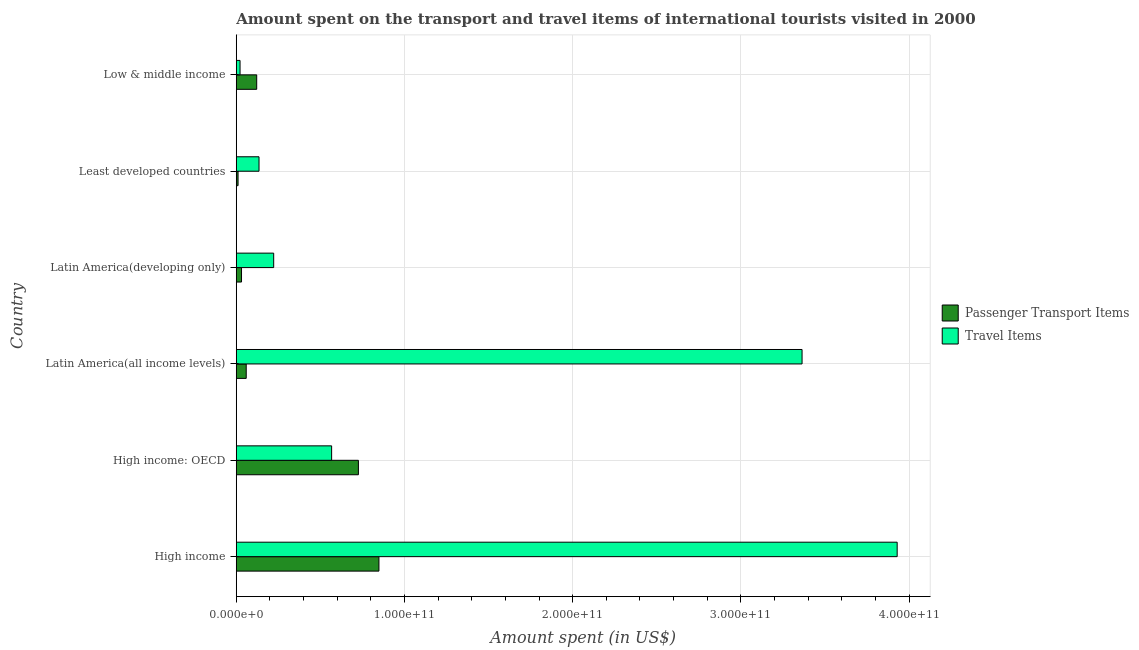How many groups of bars are there?
Your answer should be very brief. 6. Are the number of bars per tick equal to the number of legend labels?
Make the answer very short. Yes. Are the number of bars on each tick of the Y-axis equal?
Keep it short and to the point. Yes. How many bars are there on the 4th tick from the top?
Offer a terse response. 2. What is the label of the 1st group of bars from the top?
Your answer should be very brief. Low & middle income. In how many cases, is the number of bars for a given country not equal to the number of legend labels?
Your answer should be compact. 0. What is the amount spent on passenger transport items in High income?
Keep it short and to the point. 8.48e+1. Across all countries, what is the maximum amount spent in travel items?
Offer a terse response. 3.93e+11. Across all countries, what is the minimum amount spent on passenger transport items?
Provide a short and direct response. 1.08e+09. In which country was the amount spent on passenger transport items minimum?
Ensure brevity in your answer.  Least developed countries. What is the total amount spent in travel items in the graph?
Keep it short and to the point. 8.24e+11. What is the difference between the amount spent in travel items in High income and that in High income: OECD?
Offer a terse response. 3.36e+11. What is the difference between the amount spent on passenger transport items in High income and the amount spent in travel items in Latin America(all income levels)?
Keep it short and to the point. -2.52e+11. What is the average amount spent in travel items per country?
Ensure brevity in your answer.  1.37e+11. What is the difference between the amount spent in travel items and amount spent on passenger transport items in Least developed countries?
Provide a short and direct response. 1.25e+1. What is the ratio of the amount spent on passenger transport items in High income: OECD to that in Least developed countries?
Ensure brevity in your answer.  67.43. What is the difference between the highest and the second highest amount spent in travel items?
Ensure brevity in your answer.  5.65e+1. What is the difference between the highest and the lowest amount spent on passenger transport items?
Your answer should be very brief. 8.37e+1. In how many countries, is the amount spent in travel items greater than the average amount spent in travel items taken over all countries?
Ensure brevity in your answer.  2. What does the 2nd bar from the top in Least developed countries represents?
Make the answer very short. Passenger Transport Items. What does the 1st bar from the bottom in High income represents?
Keep it short and to the point. Passenger Transport Items. Are all the bars in the graph horizontal?
Keep it short and to the point. Yes. How many countries are there in the graph?
Provide a succinct answer. 6. What is the difference between two consecutive major ticks on the X-axis?
Your answer should be compact. 1.00e+11. Are the values on the major ticks of X-axis written in scientific E-notation?
Your answer should be compact. Yes. Does the graph contain any zero values?
Your answer should be very brief. No. Where does the legend appear in the graph?
Offer a terse response. Center right. How many legend labels are there?
Keep it short and to the point. 2. How are the legend labels stacked?
Make the answer very short. Vertical. What is the title of the graph?
Your response must be concise. Amount spent on the transport and travel items of international tourists visited in 2000. Does "Lowest 10% of population" appear as one of the legend labels in the graph?
Provide a short and direct response. No. What is the label or title of the X-axis?
Offer a very short reply. Amount spent (in US$). What is the label or title of the Y-axis?
Your answer should be very brief. Country. What is the Amount spent (in US$) of Passenger Transport Items in High income?
Keep it short and to the point. 8.48e+1. What is the Amount spent (in US$) in Travel Items in High income?
Provide a short and direct response. 3.93e+11. What is the Amount spent (in US$) in Passenger Transport Items in High income: OECD?
Your answer should be very brief. 7.26e+1. What is the Amount spent (in US$) of Travel Items in High income: OECD?
Keep it short and to the point. 5.67e+1. What is the Amount spent (in US$) in Passenger Transport Items in Latin America(all income levels)?
Give a very brief answer. 5.93e+09. What is the Amount spent (in US$) of Travel Items in Latin America(all income levels)?
Offer a very short reply. 3.36e+11. What is the Amount spent (in US$) in Passenger Transport Items in Latin America(developing only)?
Your answer should be very brief. 3.13e+09. What is the Amount spent (in US$) in Travel Items in Latin America(developing only)?
Provide a succinct answer. 2.23e+1. What is the Amount spent (in US$) in Passenger Transport Items in Least developed countries?
Keep it short and to the point. 1.08e+09. What is the Amount spent (in US$) in Travel Items in Least developed countries?
Make the answer very short. 1.35e+1. What is the Amount spent (in US$) in Passenger Transport Items in Low & middle income?
Offer a very short reply. 1.22e+1. What is the Amount spent (in US$) in Travel Items in Low & middle income?
Give a very brief answer. 2.26e+09. Across all countries, what is the maximum Amount spent (in US$) of Passenger Transport Items?
Your response must be concise. 8.48e+1. Across all countries, what is the maximum Amount spent (in US$) in Travel Items?
Keep it short and to the point. 3.93e+11. Across all countries, what is the minimum Amount spent (in US$) in Passenger Transport Items?
Your response must be concise. 1.08e+09. Across all countries, what is the minimum Amount spent (in US$) in Travel Items?
Provide a short and direct response. 2.26e+09. What is the total Amount spent (in US$) of Passenger Transport Items in the graph?
Ensure brevity in your answer.  1.80e+11. What is the total Amount spent (in US$) in Travel Items in the graph?
Provide a succinct answer. 8.24e+11. What is the difference between the Amount spent (in US$) of Passenger Transport Items in High income and that in High income: OECD?
Provide a succinct answer. 1.22e+1. What is the difference between the Amount spent (in US$) of Travel Items in High income and that in High income: OECD?
Give a very brief answer. 3.36e+11. What is the difference between the Amount spent (in US$) in Passenger Transport Items in High income and that in Latin America(all income levels)?
Make the answer very short. 7.89e+1. What is the difference between the Amount spent (in US$) of Travel Items in High income and that in Latin America(all income levels)?
Offer a terse response. 5.65e+1. What is the difference between the Amount spent (in US$) of Passenger Transport Items in High income and that in Latin America(developing only)?
Your answer should be compact. 8.17e+1. What is the difference between the Amount spent (in US$) in Travel Items in High income and that in Latin America(developing only)?
Make the answer very short. 3.71e+11. What is the difference between the Amount spent (in US$) of Passenger Transport Items in High income and that in Least developed countries?
Ensure brevity in your answer.  8.37e+1. What is the difference between the Amount spent (in US$) of Travel Items in High income and that in Least developed countries?
Make the answer very short. 3.79e+11. What is the difference between the Amount spent (in US$) of Passenger Transport Items in High income and that in Low & middle income?
Ensure brevity in your answer.  7.27e+1. What is the difference between the Amount spent (in US$) of Travel Items in High income and that in Low & middle income?
Ensure brevity in your answer.  3.91e+11. What is the difference between the Amount spent (in US$) in Passenger Transport Items in High income: OECD and that in Latin America(all income levels)?
Your answer should be very brief. 6.67e+1. What is the difference between the Amount spent (in US$) of Travel Items in High income: OECD and that in Latin America(all income levels)?
Keep it short and to the point. -2.80e+11. What is the difference between the Amount spent (in US$) of Passenger Transport Items in High income: OECD and that in Latin America(developing only)?
Keep it short and to the point. 6.95e+1. What is the difference between the Amount spent (in US$) in Travel Items in High income: OECD and that in Latin America(developing only)?
Offer a very short reply. 3.44e+1. What is the difference between the Amount spent (in US$) in Passenger Transport Items in High income: OECD and that in Least developed countries?
Give a very brief answer. 7.15e+1. What is the difference between the Amount spent (in US$) in Travel Items in High income: OECD and that in Least developed countries?
Ensure brevity in your answer.  4.32e+1. What is the difference between the Amount spent (in US$) of Passenger Transport Items in High income: OECD and that in Low & middle income?
Your response must be concise. 6.05e+1. What is the difference between the Amount spent (in US$) in Travel Items in High income: OECD and that in Low & middle income?
Offer a terse response. 5.44e+1. What is the difference between the Amount spent (in US$) of Passenger Transport Items in Latin America(all income levels) and that in Latin America(developing only)?
Make the answer very short. 2.79e+09. What is the difference between the Amount spent (in US$) in Travel Items in Latin America(all income levels) and that in Latin America(developing only)?
Give a very brief answer. 3.14e+11. What is the difference between the Amount spent (in US$) in Passenger Transport Items in Latin America(all income levels) and that in Least developed countries?
Your answer should be very brief. 4.85e+09. What is the difference between the Amount spent (in US$) in Travel Items in Latin America(all income levels) and that in Least developed countries?
Offer a terse response. 3.23e+11. What is the difference between the Amount spent (in US$) in Passenger Transport Items in Latin America(all income levels) and that in Low & middle income?
Offer a very short reply. -6.23e+09. What is the difference between the Amount spent (in US$) of Travel Items in Latin America(all income levels) and that in Low & middle income?
Ensure brevity in your answer.  3.34e+11. What is the difference between the Amount spent (in US$) in Passenger Transport Items in Latin America(developing only) and that in Least developed countries?
Ensure brevity in your answer.  2.06e+09. What is the difference between the Amount spent (in US$) of Travel Items in Latin America(developing only) and that in Least developed countries?
Ensure brevity in your answer.  8.72e+09. What is the difference between the Amount spent (in US$) in Passenger Transport Items in Latin America(developing only) and that in Low & middle income?
Offer a terse response. -9.02e+09. What is the difference between the Amount spent (in US$) in Travel Items in Latin America(developing only) and that in Low & middle income?
Ensure brevity in your answer.  2.00e+1. What is the difference between the Amount spent (in US$) of Passenger Transport Items in Least developed countries and that in Low & middle income?
Your response must be concise. -1.11e+1. What is the difference between the Amount spent (in US$) of Travel Items in Least developed countries and that in Low & middle income?
Provide a succinct answer. 1.13e+1. What is the difference between the Amount spent (in US$) in Passenger Transport Items in High income and the Amount spent (in US$) in Travel Items in High income: OECD?
Make the answer very short. 2.81e+1. What is the difference between the Amount spent (in US$) of Passenger Transport Items in High income and the Amount spent (in US$) of Travel Items in Latin America(all income levels)?
Offer a terse response. -2.52e+11. What is the difference between the Amount spent (in US$) in Passenger Transport Items in High income and the Amount spent (in US$) in Travel Items in Latin America(developing only)?
Offer a terse response. 6.26e+1. What is the difference between the Amount spent (in US$) of Passenger Transport Items in High income and the Amount spent (in US$) of Travel Items in Least developed countries?
Your answer should be compact. 7.13e+1. What is the difference between the Amount spent (in US$) of Passenger Transport Items in High income and the Amount spent (in US$) of Travel Items in Low & middle income?
Your answer should be compact. 8.26e+1. What is the difference between the Amount spent (in US$) of Passenger Transport Items in High income: OECD and the Amount spent (in US$) of Travel Items in Latin America(all income levels)?
Keep it short and to the point. -2.64e+11. What is the difference between the Amount spent (in US$) of Passenger Transport Items in High income: OECD and the Amount spent (in US$) of Travel Items in Latin America(developing only)?
Your answer should be compact. 5.04e+1. What is the difference between the Amount spent (in US$) of Passenger Transport Items in High income: OECD and the Amount spent (in US$) of Travel Items in Least developed countries?
Keep it short and to the point. 5.91e+1. What is the difference between the Amount spent (in US$) in Passenger Transport Items in High income: OECD and the Amount spent (in US$) in Travel Items in Low & middle income?
Ensure brevity in your answer.  7.04e+1. What is the difference between the Amount spent (in US$) of Passenger Transport Items in Latin America(all income levels) and the Amount spent (in US$) of Travel Items in Latin America(developing only)?
Provide a succinct answer. -1.63e+1. What is the difference between the Amount spent (in US$) of Passenger Transport Items in Latin America(all income levels) and the Amount spent (in US$) of Travel Items in Least developed countries?
Provide a short and direct response. -7.61e+09. What is the difference between the Amount spent (in US$) of Passenger Transport Items in Latin America(all income levels) and the Amount spent (in US$) of Travel Items in Low & middle income?
Make the answer very short. 3.67e+09. What is the difference between the Amount spent (in US$) in Passenger Transport Items in Latin America(developing only) and the Amount spent (in US$) in Travel Items in Least developed countries?
Make the answer very short. -1.04e+1. What is the difference between the Amount spent (in US$) of Passenger Transport Items in Latin America(developing only) and the Amount spent (in US$) of Travel Items in Low & middle income?
Give a very brief answer. 8.73e+08. What is the difference between the Amount spent (in US$) in Passenger Transport Items in Least developed countries and the Amount spent (in US$) in Travel Items in Low & middle income?
Give a very brief answer. -1.18e+09. What is the average Amount spent (in US$) in Passenger Transport Items per country?
Provide a succinct answer. 3.00e+1. What is the average Amount spent (in US$) of Travel Items per country?
Keep it short and to the point. 1.37e+11. What is the difference between the Amount spent (in US$) in Passenger Transport Items and Amount spent (in US$) in Travel Items in High income?
Provide a short and direct response. -3.08e+11. What is the difference between the Amount spent (in US$) in Passenger Transport Items and Amount spent (in US$) in Travel Items in High income: OECD?
Give a very brief answer. 1.59e+1. What is the difference between the Amount spent (in US$) in Passenger Transport Items and Amount spent (in US$) in Travel Items in Latin America(all income levels)?
Your response must be concise. -3.30e+11. What is the difference between the Amount spent (in US$) in Passenger Transport Items and Amount spent (in US$) in Travel Items in Latin America(developing only)?
Keep it short and to the point. -1.91e+1. What is the difference between the Amount spent (in US$) of Passenger Transport Items and Amount spent (in US$) of Travel Items in Least developed countries?
Provide a succinct answer. -1.25e+1. What is the difference between the Amount spent (in US$) in Passenger Transport Items and Amount spent (in US$) in Travel Items in Low & middle income?
Your answer should be very brief. 9.90e+09. What is the ratio of the Amount spent (in US$) in Passenger Transport Items in High income to that in High income: OECD?
Provide a succinct answer. 1.17. What is the ratio of the Amount spent (in US$) of Travel Items in High income to that in High income: OECD?
Your response must be concise. 6.93. What is the ratio of the Amount spent (in US$) of Passenger Transport Items in High income to that in Latin America(all income levels)?
Keep it short and to the point. 14.31. What is the ratio of the Amount spent (in US$) in Travel Items in High income to that in Latin America(all income levels)?
Offer a terse response. 1.17. What is the ratio of the Amount spent (in US$) in Passenger Transport Items in High income to that in Latin America(developing only)?
Give a very brief answer. 27.08. What is the ratio of the Amount spent (in US$) in Travel Items in High income to that in Latin America(developing only)?
Provide a short and direct response. 17.66. What is the ratio of the Amount spent (in US$) in Passenger Transport Items in High income to that in Least developed countries?
Give a very brief answer. 78.76. What is the ratio of the Amount spent (in US$) in Travel Items in High income to that in Least developed countries?
Your answer should be compact. 29.03. What is the ratio of the Amount spent (in US$) of Passenger Transport Items in High income to that in Low & middle income?
Offer a terse response. 6.98. What is the ratio of the Amount spent (in US$) in Travel Items in High income to that in Low & middle income?
Provide a short and direct response. 173.89. What is the ratio of the Amount spent (in US$) in Passenger Transport Items in High income: OECD to that in Latin America(all income levels)?
Ensure brevity in your answer.  12.25. What is the ratio of the Amount spent (in US$) of Travel Items in High income: OECD to that in Latin America(all income levels)?
Make the answer very short. 0.17. What is the ratio of the Amount spent (in US$) in Passenger Transport Items in High income: OECD to that in Latin America(developing only)?
Provide a succinct answer. 23.18. What is the ratio of the Amount spent (in US$) in Travel Items in High income: OECD to that in Latin America(developing only)?
Offer a very short reply. 2.55. What is the ratio of the Amount spent (in US$) of Passenger Transport Items in High income: OECD to that in Least developed countries?
Provide a short and direct response. 67.43. What is the ratio of the Amount spent (in US$) in Travel Items in High income: OECD to that in Least developed countries?
Provide a succinct answer. 4.19. What is the ratio of the Amount spent (in US$) of Passenger Transport Items in High income: OECD to that in Low & middle income?
Your answer should be very brief. 5.97. What is the ratio of the Amount spent (in US$) in Travel Items in High income: OECD to that in Low & middle income?
Ensure brevity in your answer.  25.09. What is the ratio of the Amount spent (in US$) in Passenger Transport Items in Latin America(all income levels) to that in Latin America(developing only)?
Keep it short and to the point. 1.89. What is the ratio of the Amount spent (in US$) of Travel Items in Latin America(all income levels) to that in Latin America(developing only)?
Provide a succinct answer. 15.12. What is the ratio of the Amount spent (in US$) of Passenger Transport Items in Latin America(all income levels) to that in Least developed countries?
Provide a succinct answer. 5.5. What is the ratio of the Amount spent (in US$) in Travel Items in Latin America(all income levels) to that in Least developed countries?
Your answer should be very brief. 24.85. What is the ratio of the Amount spent (in US$) of Passenger Transport Items in Latin America(all income levels) to that in Low & middle income?
Provide a short and direct response. 0.49. What is the ratio of the Amount spent (in US$) of Travel Items in Latin America(all income levels) to that in Low & middle income?
Make the answer very short. 148.87. What is the ratio of the Amount spent (in US$) of Passenger Transport Items in Latin America(developing only) to that in Least developed countries?
Offer a terse response. 2.91. What is the ratio of the Amount spent (in US$) in Travel Items in Latin America(developing only) to that in Least developed countries?
Make the answer very short. 1.64. What is the ratio of the Amount spent (in US$) in Passenger Transport Items in Latin America(developing only) to that in Low & middle income?
Ensure brevity in your answer.  0.26. What is the ratio of the Amount spent (in US$) in Travel Items in Latin America(developing only) to that in Low & middle income?
Your response must be concise. 9.85. What is the ratio of the Amount spent (in US$) of Passenger Transport Items in Least developed countries to that in Low & middle income?
Ensure brevity in your answer.  0.09. What is the ratio of the Amount spent (in US$) of Travel Items in Least developed countries to that in Low & middle income?
Make the answer very short. 5.99. What is the difference between the highest and the second highest Amount spent (in US$) in Passenger Transport Items?
Keep it short and to the point. 1.22e+1. What is the difference between the highest and the second highest Amount spent (in US$) in Travel Items?
Ensure brevity in your answer.  5.65e+1. What is the difference between the highest and the lowest Amount spent (in US$) in Passenger Transport Items?
Ensure brevity in your answer.  8.37e+1. What is the difference between the highest and the lowest Amount spent (in US$) of Travel Items?
Keep it short and to the point. 3.91e+11. 